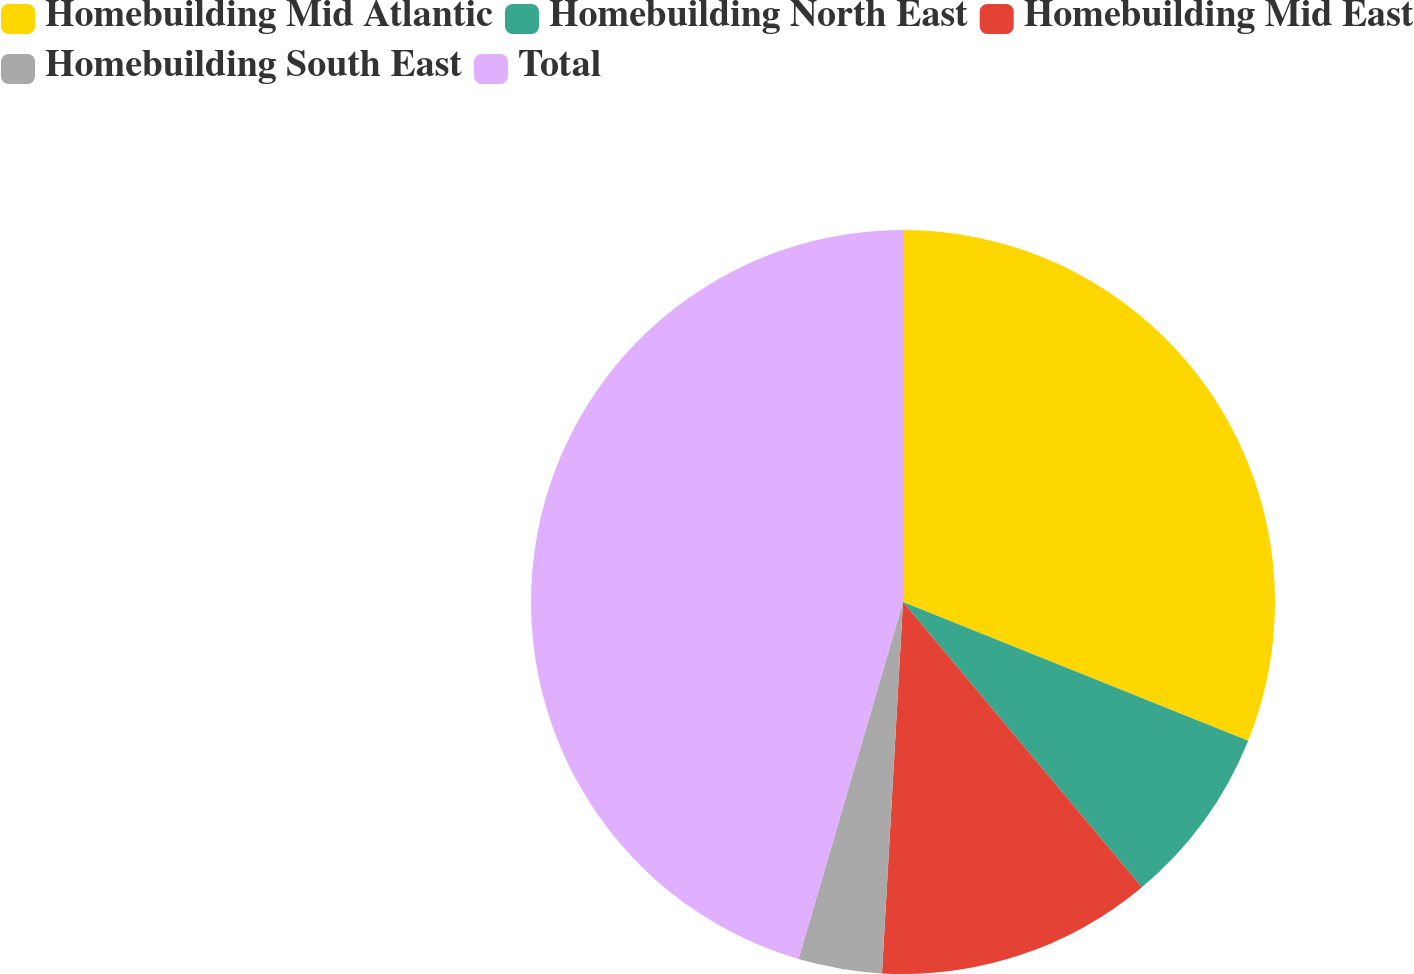Convert chart. <chart><loc_0><loc_0><loc_500><loc_500><pie_chart><fcel>Homebuilding Mid Atlantic<fcel>Homebuilding North East<fcel>Homebuilding Mid East<fcel>Homebuilding South East<fcel>Total<nl><fcel>31.08%<fcel>7.82%<fcel>12.0%<fcel>3.63%<fcel>45.47%<nl></chart> 